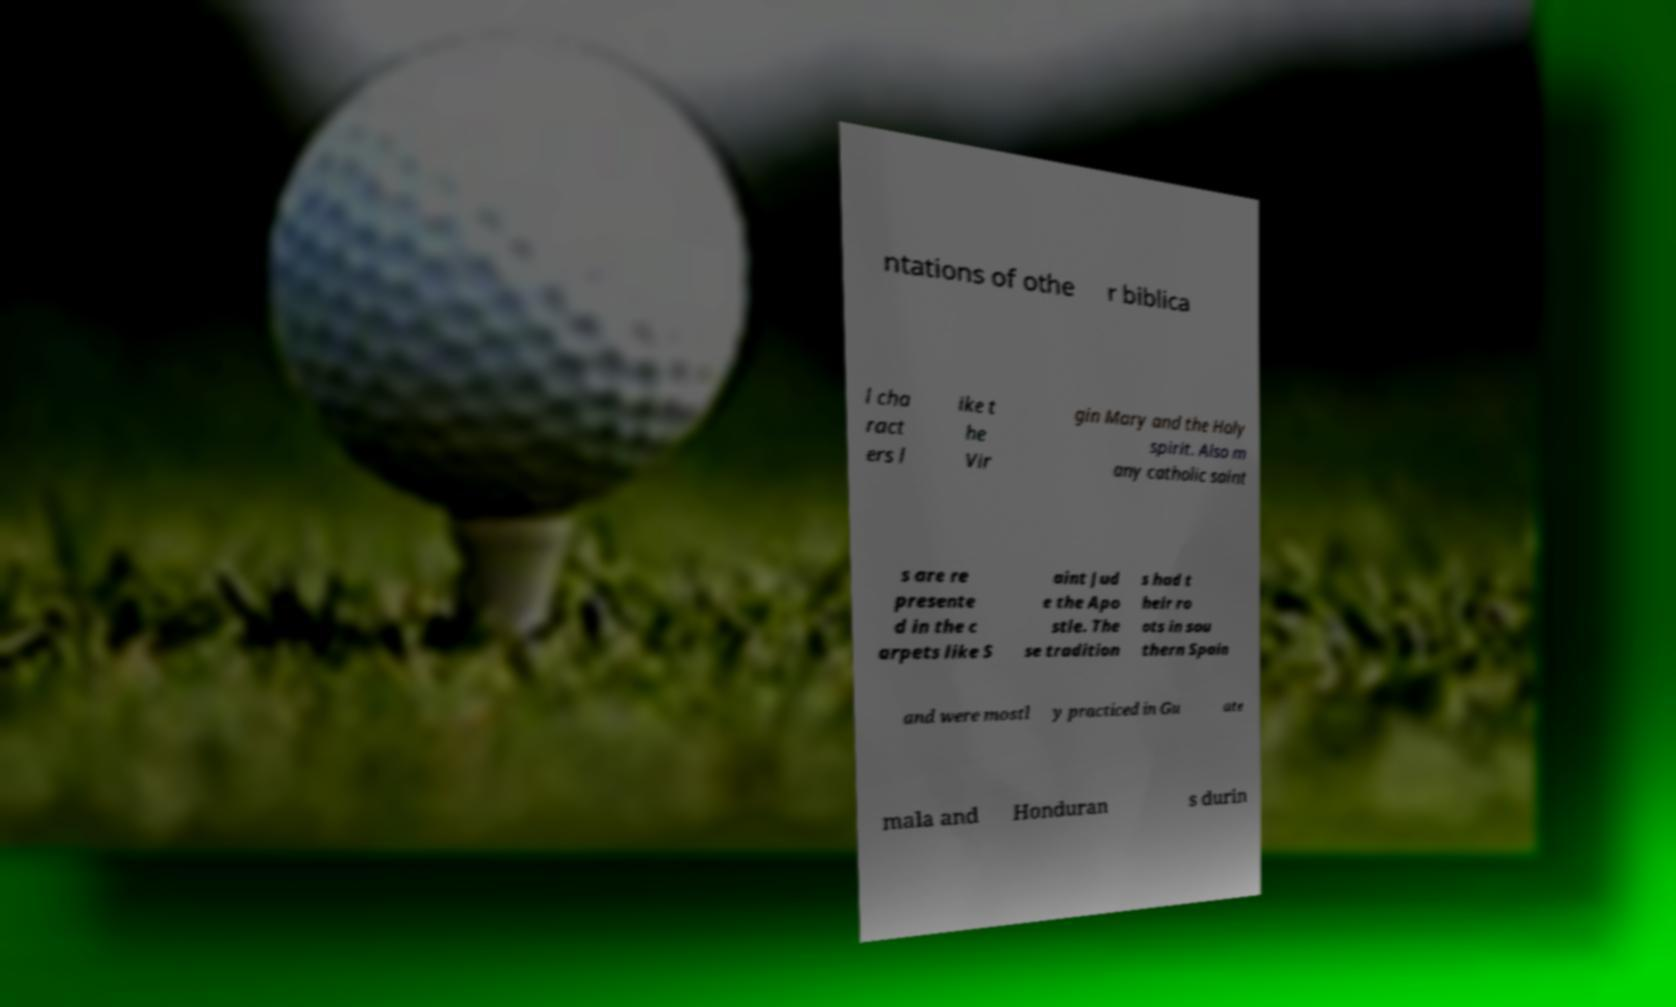Could you assist in decoding the text presented in this image and type it out clearly? ntations of othe r biblica l cha ract ers l ike t he Vir gin Mary and the Holy spirit. Also m any catholic saint s are re presente d in the c arpets like S aint Jud e the Apo stle. The se tradition s had t heir ro ots in sou thern Spain and were mostl y practiced in Gu ate mala and Honduran s durin 